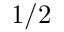Convert formula to latex. <formula><loc_0><loc_0><loc_500><loc_500>1 / 2</formula> 